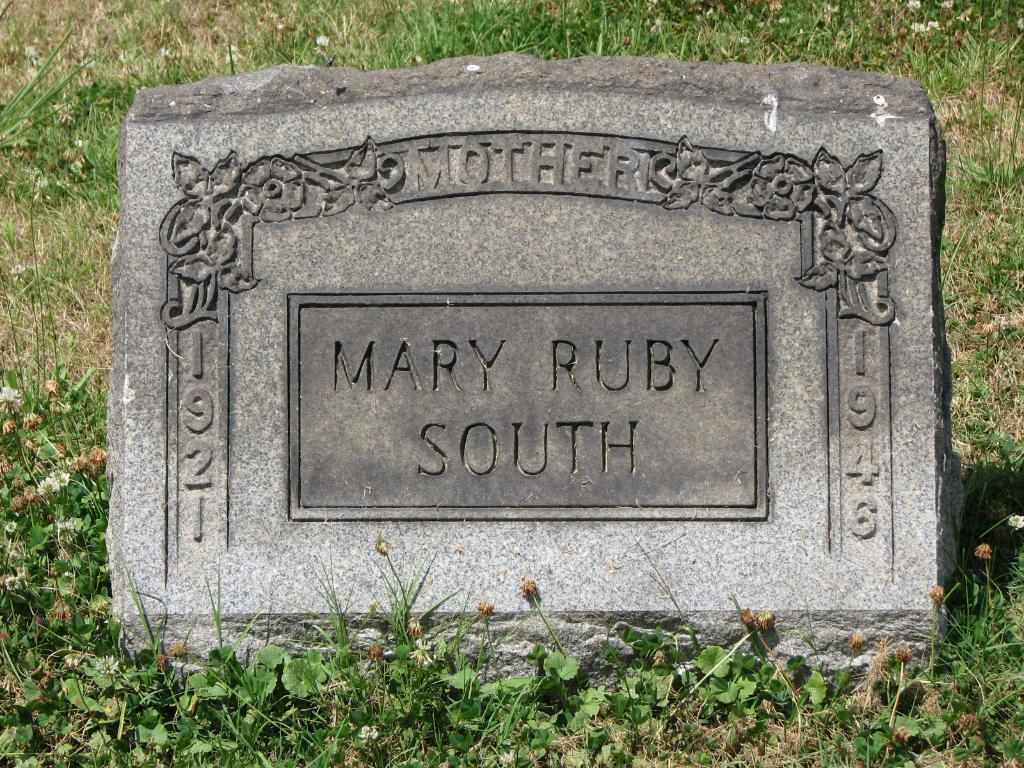What is the main object in the image? There is a gravel board in the image. What is written or printed on the gravel board? The gravel board has text on it. What type of vegetation can be seen in the image? There is grass in the image. Are there any plants other than grass in the image? Yes, flower plants are present at the bottom of the image. What type of stone is the creator of the gravel board using to create the text? There is no information about the creator of the gravel board or the type of stone used in the image. 